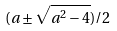Convert formula to latex. <formula><loc_0><loc_0><loc_500><loc_500>( a \pm \sqrt { a ^ { 2 } - 4 } ) / 2</formula> 